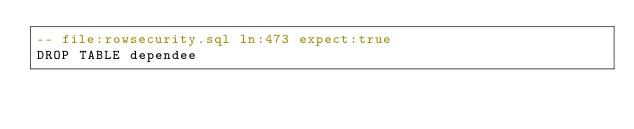Convert code to text. <code><loc_0><loc_0><loc_500><loc_500><_SQL_>-- file:rowsecurity.sql ln:473 expect:true
DROP TABLE dependee
</code> 